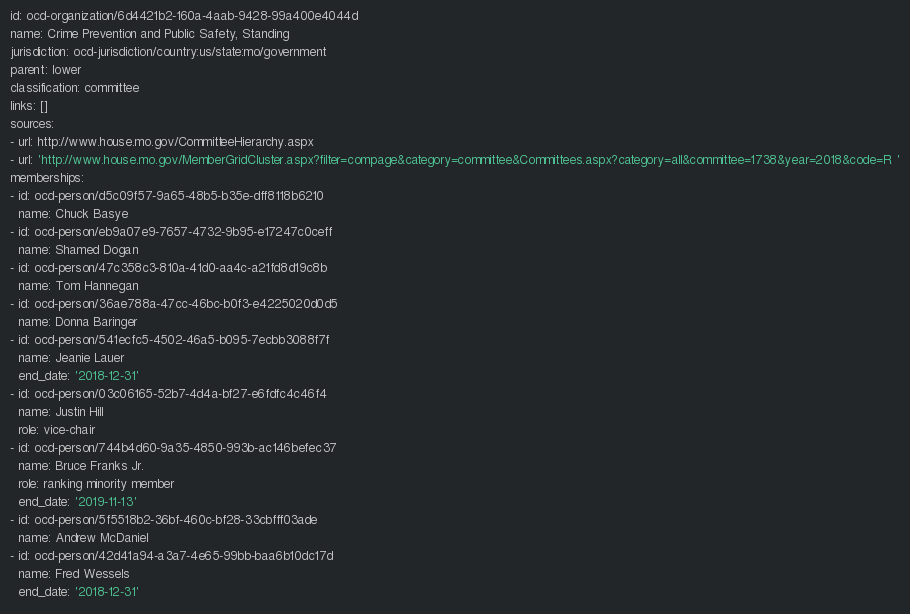Convert code to text. <code><loc_0><loc_0><loc_500><loc_500><_YAML_>id: ocd-organization/6d4421b2-160a-4aab-9428-99a400e4044d
name: Crime Prevention and Public Safety, Standing
jurisdiction: ocd-jurisdiction/country:us/state:mo/government
parent: lower
classification: committee
links: []
sources:
- url: http://www.house.mo.gov/CommitteeHierarchy.aspx
- url: 'http://www.house.mo.gov/MemberGridCluster.aspx?filter=compage&category=committee&Committees.aspx?category=all&committee=1738&year=2018&code=R '
memberships:
- id: ocd-person/d5c09f57-9a65-48b5-b35e-dff8118b6210
  name: Chuck Basye
- id: ocd-person/eb9a07e9-7657-4732-9b95-e17247c0ceff
  name: Shamed Dogan
- id: ocd-person/47c358c3-810a-41d0-aa4c-a21fd8d19c8b
  name: Tom Hannegan
- id: ocd-person/36ae788a-47cc-46bc-b0f3-e4225020d0d5
  name: Donna Baringer
- id: ocd-person/541ecfc5-4502-46a5-b095-7ecbb3088f7f
  name: Jeanie Lauer
  end_date: '2018-12-31'
- id: ocd-person/03c06165-52b7-4d4a-bf27-e6fdfc4c46f4
  name: Justin Hill
  role: vice-chair
- id: ocd-person/744b4d60-9a35-4850-993b-ac146befec37
  name: Bruce Franks Jr.
  role: ranking minority member
  end_date: '2019-11-13'
- id: ocd-person/5f5518b2-36bf-460c-bf28-33cbfff03ade
  name: Andrew McDaniel
- id: ocd-person/42d41a94-a3a7-4e65-99bb-baa6b10dc17d
  name: Fred Wessels
  end_date: '2018-12-31'
</code> 